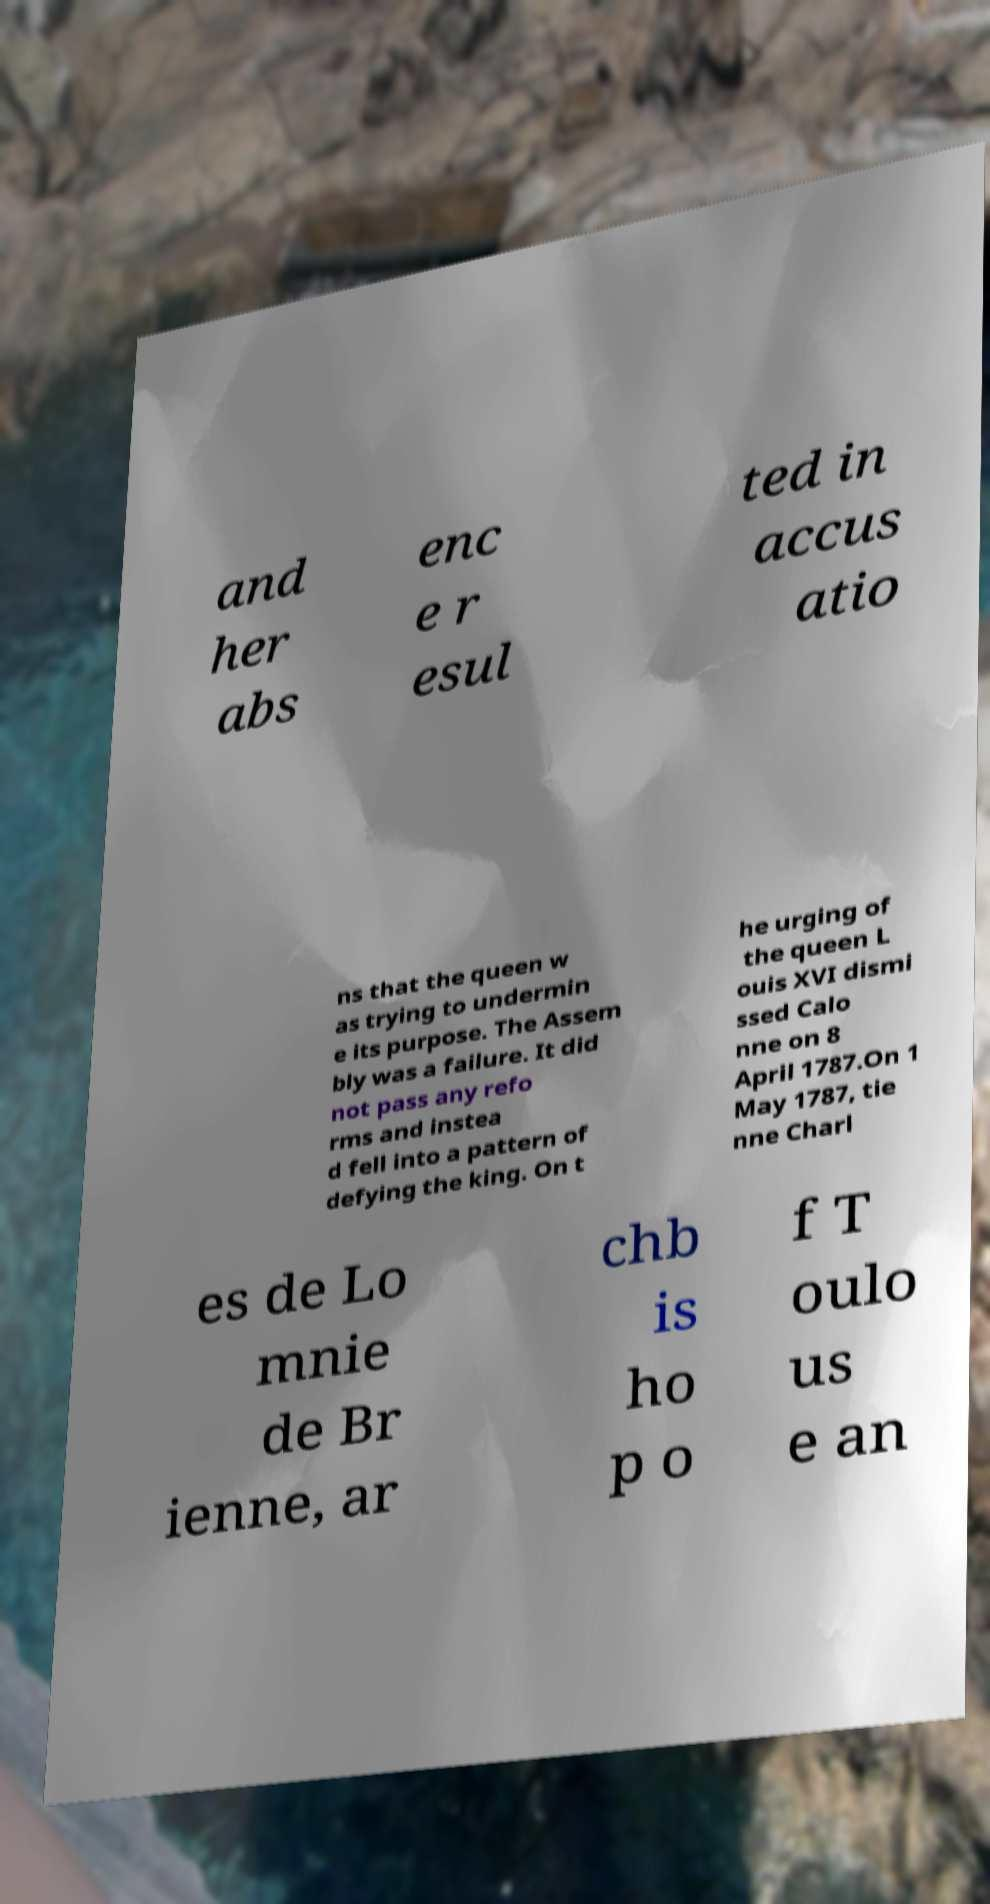Please read and relay the text visible in this image. What does it say? and her abs enc e r esul ted in accus atio ns that the queen w as trying to undermin e its purpose. The Assem bly was a failure. It did not pass any refo rms and instea d fell into a pattern of defying the king. On t he urging of the queen L ouis XVI dismi ssed Calo nne on 8 April 1787.On 1 May 1787, tie nne Charl es de Lo mnie de Br ienne, ar chb is ho p o f T oulo us e an 